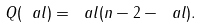Convert formula to latex. <formula><loc_0><loc_0><loc_500><loc_500>Q ( \ a l ) = \ a l ( n - 2 - \ a l ) .</formula> 